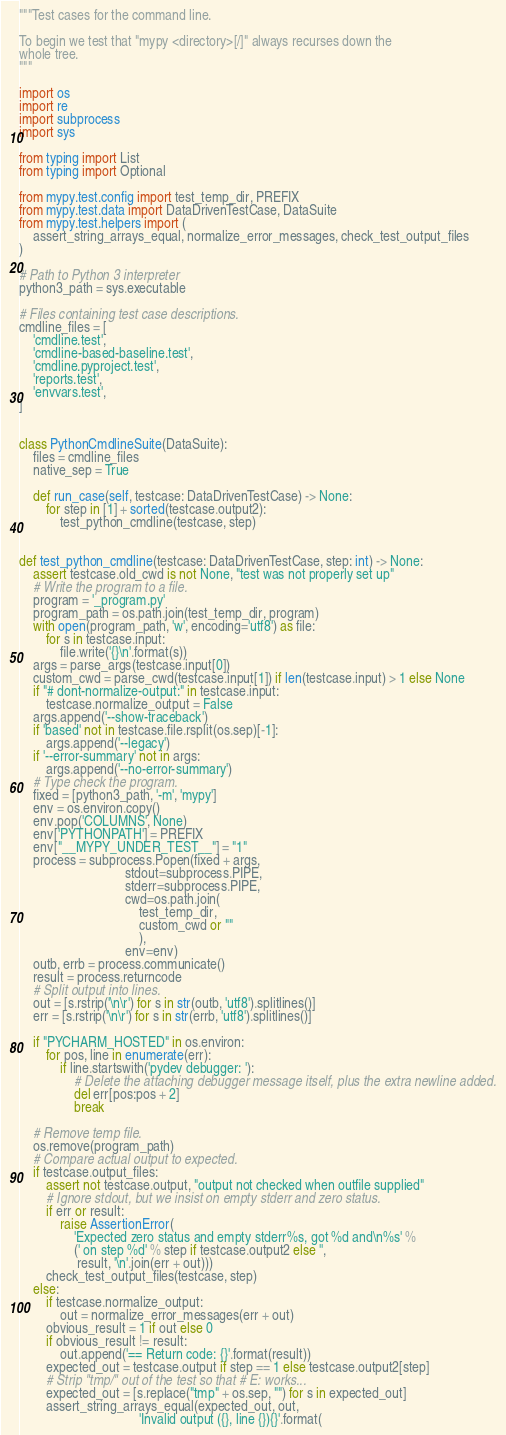Convert code to text. <code><loc_0><loc_0><loc_500><loc_500><_Python_>"""Test cases for the command line.

To begin we test that "mypy <directory>[/]" always recurses down the
whole tree.
"""

import os
import re
import subprocess
import sys

from typing import List
from typing import Optional

from mypy.test.config import test_temp_dir, PREFIX
from mypy.test.data import DataDrivenTestCase, DataSuite
from mypy.test.helpers import (
    assert_string_arrays_equal, normalize_error_messages, check_test_output_files
)

# Path to Python 3 interpreter
python3_path = sys.executable

# Files containing test case descriptions.
cmdline_files = [
    'cmdline.test',
    'cmdline-based-baseline.test',
    'cmdline.pyproject.test',
    'reports.test',
    'envvars.test',
]


class PythonCmdlineSuite(DataSuite):
    files = cmdline_files
    native_sep = True

    def run_case(self, testcase: DataDrivenTestCase) -> None:
        for step in [1] + sorted(testcase.output2):
            test_python_cmdline(testcase, step)


def test_python_cmdline(testcase: DataDrivenTestCase, step: int) -> None:
    assert testcase.old_cwd is not None, "test was not properly set up"
    # Write the program to a file.
    program = '_program.py'
    program_path = os.path.join(test_temp_dir, program)
    with open(program_path, 'w', encoding='utf8') as file:
        for s in testcase.input:
            file.write('{}\n'.format(s))
    args = parse_args(testcase.input[0])
    custom_cwd = parse_cwd(testcase.input[1]) if len(testcase.input) > 1 else None
    if "# dont-normalize-output:" in testcase.input:
        testcase.normalize_output = False
    args.append('--show-traceback')
    if 'based' not in testcase.file.rsplit(os.sep)[-1]:
        args.append('--legacy')
    if '--error-summary' not in args:
        args.append('--no-error-summary')
    # Type check the program.
    fixed = [python3_path, '-m', 'mypy']
    env = os.environ.copy()
    env.pop('COLUMNS', None)
    env['PYTHONPATH'] = PREFIX
    env["__MYPY_UNDER_TEST__"] = "1"
    process = subprocess.Popen(fixed + args,
                               stdout=subprocess.PIPE,
                               stderr=subprocess.PIPE,
                               cwd=os.path.join(
                                   test_temp_dir,
                                   custom_cwd or ""
                                   ),
                               env=env)
    outb, errb = process.communicate()
    result = process.returncode
    # Split output into lines.
    out = [s.rstrip('\n\r') for s in str(outb, 'utf8').splitlines()]
    err = [s.rstrip('\n\r') for s in str(errb, 'utf8').splitlines()]

    if "PYCHARM_HOSTED" in os.environ:
        for pos, line in enumerate(err):
            if line.startswith('pydev debugger: '):
                # Delete the attaching debugger message itself, plus the extra newline added.
                del err[pos:pos + 2]
                break

    # Remove temp file.
    os.remove(program_path)
    # Compare actual output to expected.
    if testcase.output_files:
        assert not testcase.output, "output not checked when outfile supplied"
        # Ignore stdout, but we insist on empty stderr and zero status.
        if err or result:
            raise AssertionError(
                'Expected zero status and empty stderr%s, got %d and\n%s' %
                (' on step %d' % step if testcase.output2 else '',
                 result, '\n'.join(err + out)))
        check_test_output_files(testcase, step)
    else:
        if testcase.normalize_output:
            out = normalize_error_messages(err + out)
        obvious_result = 1 if out else 0
        if obvious_result != result:
            out.append('== Return code: {}'.format(result))
        expected_out = testcase.output if step == 1 else testcase.output2[step]
        # Strip "tmp/" out of the test so that # E: works...
        expected_out = [s.replace("tmp" + os.sep, "") for s in expected_out]
        assert_string_arrays_equal(expected_out, out,
                                   'Invalid output ({}, line {}){}'.format(</code> 